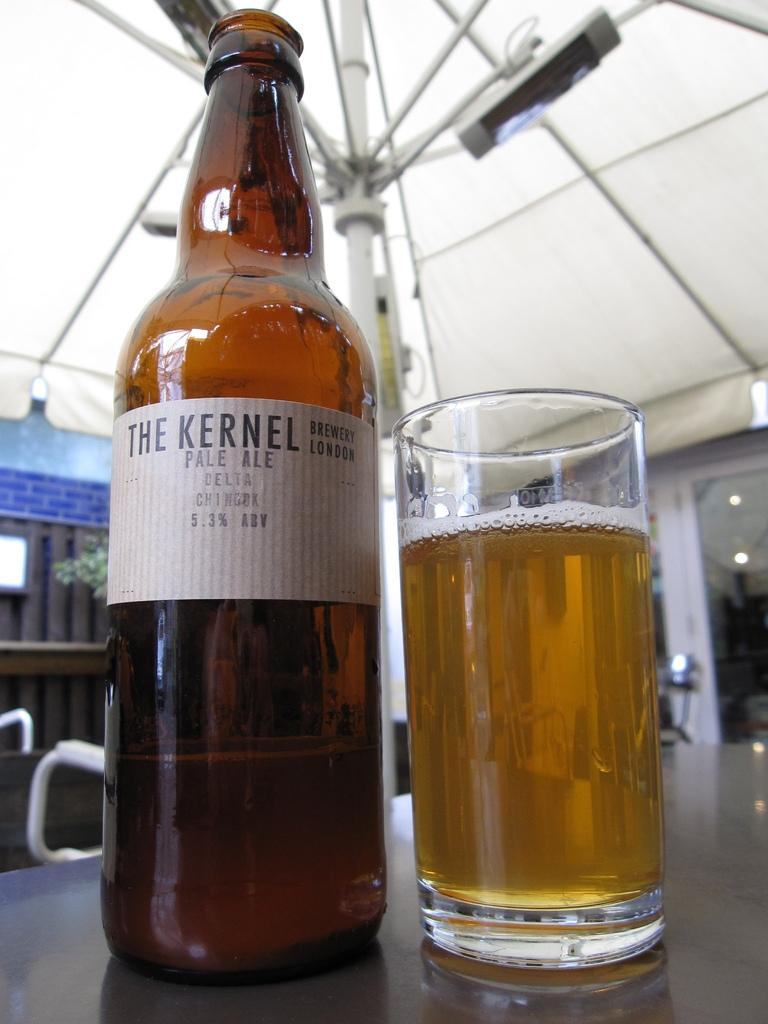<image>
Describe the image concisely. A bottle of The Kernel Pale Ale next to a full glass. 